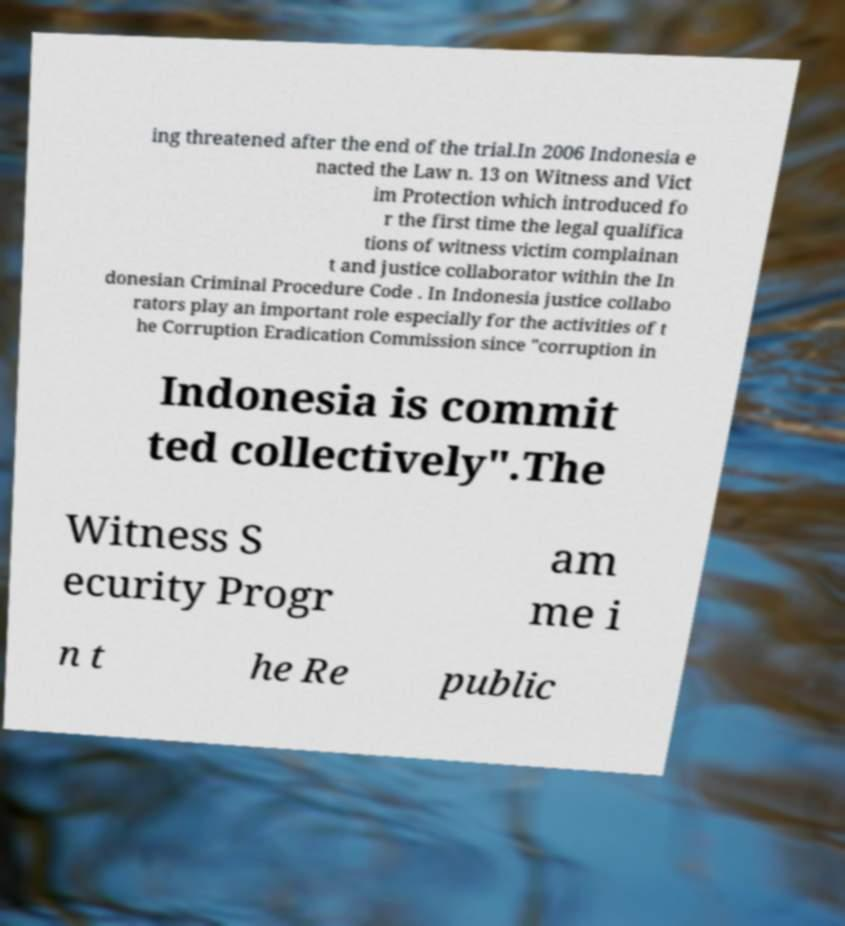Can you accurately transcribe the text from the provided image for me? ing threatened after the end of the trial.In 2006 Indonesia e nacted the Law n. 13 on Witness and Vict im Protection which introduced fo r the first time the legal qualifica tions of witness victim complainan t and justice collaborator within the In donesian Criminal Procedure Code . In Indonesia justice collabo rators play an important role especially for the activities of t he Corruption Eradication Commission since "corruption in Indonesia is commit ted collectively".The Witness S ecurity Progr am me i n t he Re public 